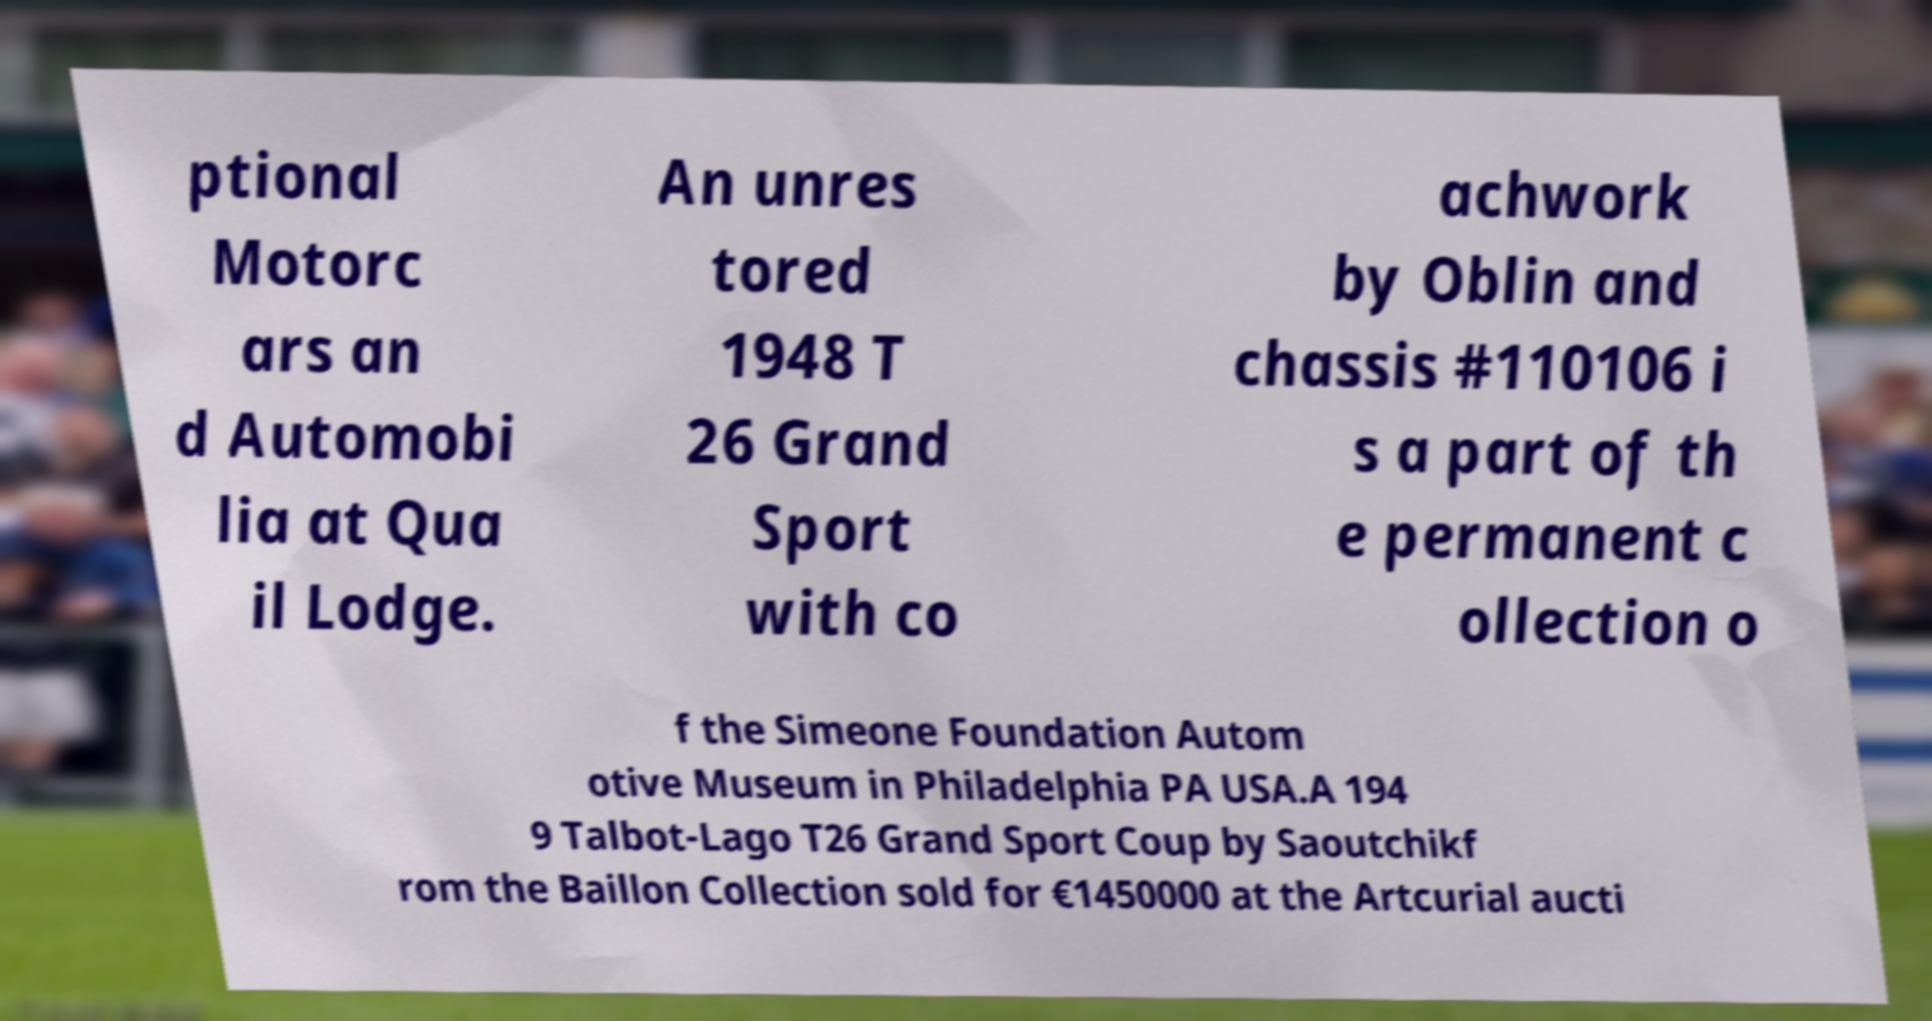There's text embedded in this image that I need extracted. Can you transcribe it verbatim? ptional Motorc ars an d Automobi lia at Qua il Lodge. An unres tored 1948 T 26 Grand Sport with co achwork by Oblin and chassis #110106 i s a part of th e permanent c ollection o f the Simeone Foundation Autom otive Museum in Philadelphia PA USA.A 194 9 Talbot-Lago T26 Grand Sport Coup by Saoutchikf rom the Baillon Collection sold for €1450000 at the Artcurial aucti 